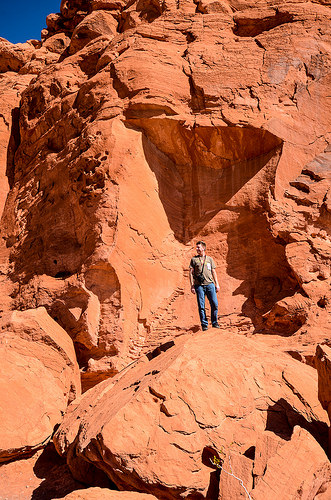<image>
Is there a man in front of the rock? Yes. The man is positioned in front of the rock, appearing closer to the camera viewpoint. 